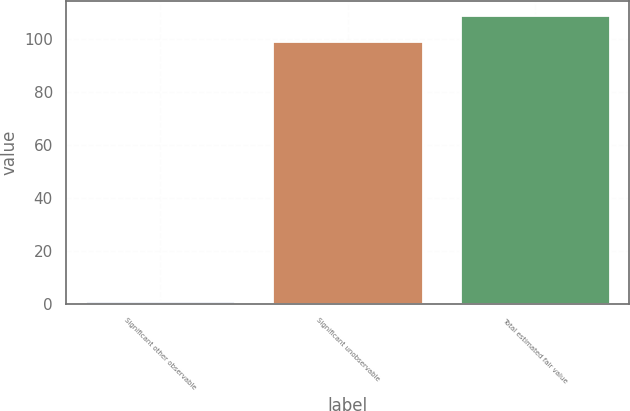Convert chart. <chart><loc_0><loc_0><loc_500><loc_500><bar_chart><fcel>Significant other observable<fcel>Significant unobservable<fcel>Total estimated fair value<nl><fcel>1<fcel>99<fcel>108.9<nl></chart> 